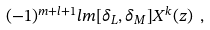Convert formula to latex. <formula><loc_0><loc_0><loc_500><loc_500>( - 1 ) ^ { m + l + 1 } l m [ \delta _ { L } , \delta _ { M } ] X ^ { k } ( z ) \ ,</formula> 